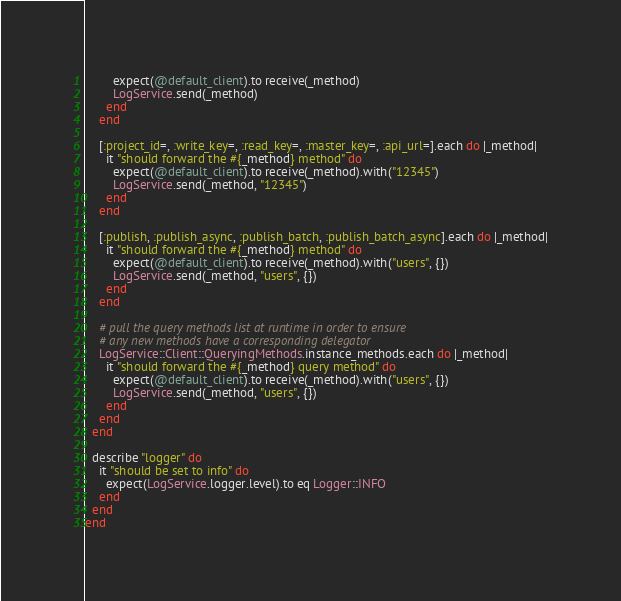<code> <loc_0><loc_0><loc_500><loc_500><_Ruby_>        expect(@default_client).to receive(_method)
        LogService.send(_method)
      end
    end

    [:project_id=, :write_key=, :read_key=, :master_key=, :api_url=].each do |_method|
      it "should forward the #{_method} method" do
        expect(@default_client).to receive(_method).with("12345")
        LogService.send(_method, "12345")
      end
    end

    [:publish, :publish_async, :publish_batch, :publish_batch_async].each do |_method|
      it "should forward the #{_method} method" do
        expect(@default_client).to receive(_method).with("users", {})
        LogService.send(_method, "users", {})
      end
    end

    # pull the query methods list at runtime in order to ensure
    # any new methods have a corresponding delegator
    LogService::Client::QueryingMethods.instance_methods.each do |_method|
      it "should forward the #{_method} query method" do
        expect(@default_client).to receive(_method).with("users", {})
        LogService.send(_method, "users", {})
      end
    end
  end

  describe "logger" do
    it "should be set to info" do
      expect(LogService.logger.level).to eq Logger::INFO
    end
  end
end
</code> 